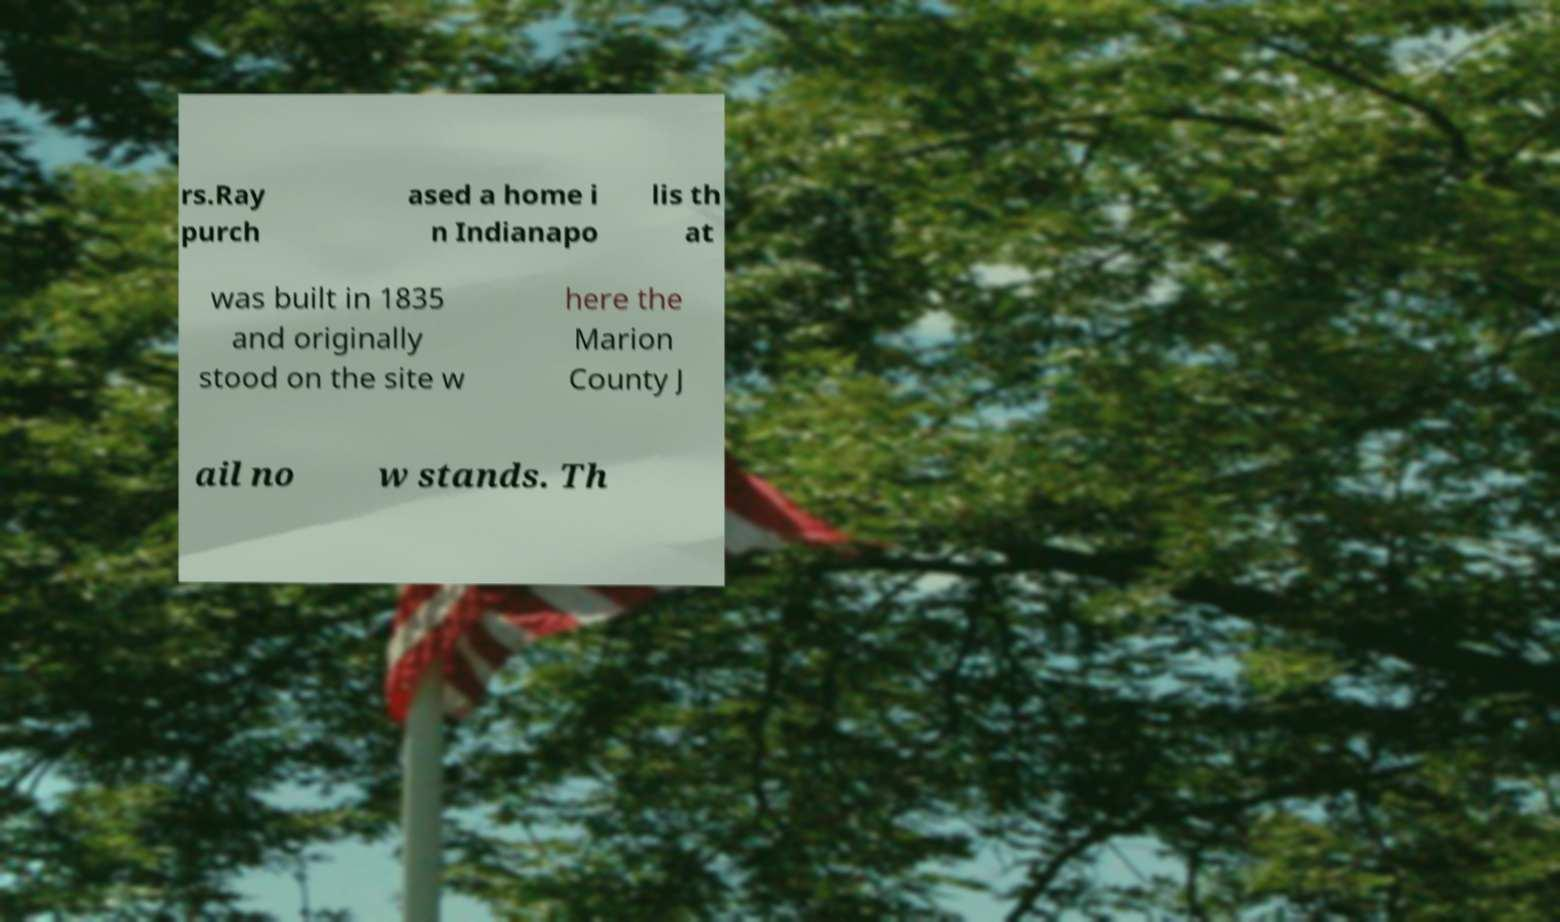For documentation purposes, I need the text within this image transcribed. Could you provide that? rs.Ray purch ased a home i n Indianapo lis th at was built in 1835 and originally stood on the site w here the Marion County J ail no w stands. Th 